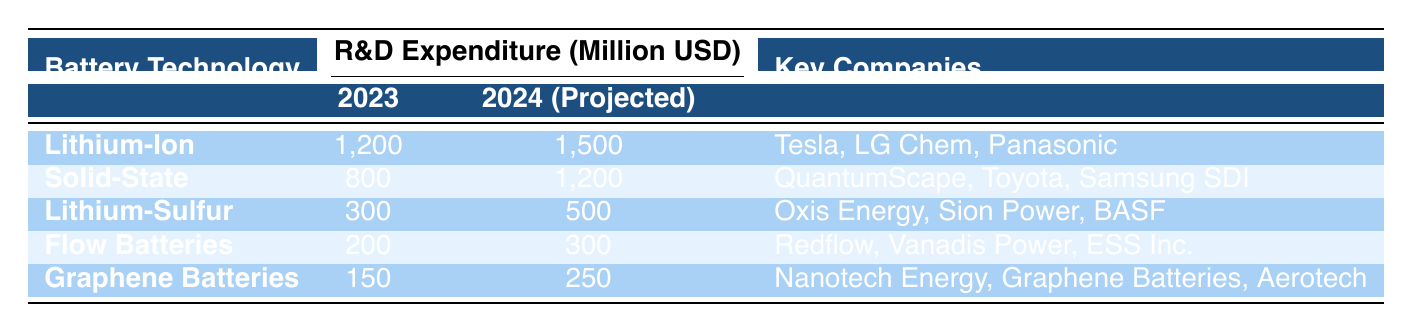What is the R&D expenditure for Lithium-Ion batteries in 2023? According to the table, the expenditure for Lithium-Ion batteries in 2023 is listed directly under the "2023 Expenditure (Million USD)" column next to the Lithium-Ion technology row. It shows a value of 1,200 million USD.
Answer: 1,200 million USD How much is the projected R&D expenditure for Solid-State batteries in 2024? The projected expenditure for Solid-State batteries in 2024 can be found in the "2024 (Projected)" column next to the Solid-State technology row in the table. The value shown is 1,200 million USD.
Answer: 1,200 million USD Which battery technology has the highest R&D expenditure in 2023? The highest expenditure in 2023 can be determined by comparing all values in the "2023 Expenditure (Million USD)" column. Lithium-Ion has the largest value at 1,200 million USD, higher than Solid-State (800), Lithium-Sulfur (300), Flow Batteries (200), and Graphene Batteries (150).
Answer: Lithium-Ion What is the total R&D expenditure projected for all listed technologies in 2024? To find the total projected expenditure for 2024, sum the values in the "2024 (Projected)" column: 1,500 (Lithium-Ion) + 1,200 (Solid-State) + 500 (Lithium-Sulfur) + 300 (Flow Batteries) + 250 (Graphene Batteries) equals 3,750 million USD.
Answer: 3,750 million USD Is there any battery technology with an expenditure less than 300 million USD for 2023? By reviewing the "2023 Expenditure (Million USD)" column, the technologies with expenditures below 300 million USD are Flow Batteries at 200 million USD and Graphene Batteries at 150 million USD. Thus, the answer is yes.
Answer: Yes How much more is the projected expenditure for Lithium-Ion batteries in 2024 compared to 2023? To find the difference, subtract the 2023 expenditure from the projected 2024 expenditure for Lithium-Ion: 1,500 (2024) - 1,200 (2023) equals 300 million USD.
Answer: 300 million USD Which technology has the lowest projected expenditure in 2024? Comparing the values in the "2024 (Projected)" column, Graphene Batteries show the lowest amount at 250 million USD, which is less than all other projected expenditures.
Answer: Graphene Batteries Are there any key companies associated with Lithium-Sulfur batteries listed in the table? The table indicates the key companies for each technology, specifically in the row for Lithium-Sulfur batteries, which lists Oxis Energy, Sion Power, and BASF, confirming that there are indeed companies associated with this technology.
Answer: Yes 